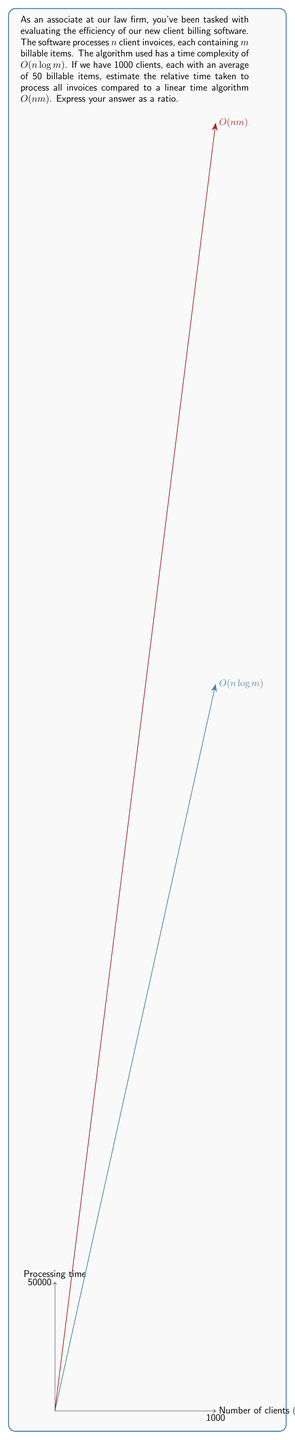Solve this math problem. Let's approach this step-by-step:

1) The given time complexity for the new algorithm is $O(n \log m)$, where:
   $n$ = number of clients = 1000
   $m$ = average number of billable items per client = 50

2) The linear time algorithm has a complexity of $O(nm)$

3) To compare, let's calculate the time for each:

   For $O(n \log m)$:
   Time $\approx c_1 \cdot n \log m = c_1 \cdot 1000 \log 50$

   For $O(nm)$:
   Time $\approx c_2 \cdot nm = c_2 \cdot 1000 \cdot 50 = c_2 \cdot 50000$

   Where $c_1$ and $c_2$ are constants.

4) The ratio of these times will be:

   $$\frac{\text{Time for } O(n \log m)}{\text{Time for } O(nm)} = \frac{c_1 \cdot 1000 \log 50}{c_2 \cdot 50000}$$

5) Assuming $c_1 \approx c_2$ (which is reasonable for comparing asymptotic complexities), we can simplify:

   $$\text{Ratio} \approx \frac{1000 \log 50}{50000} = \frac{\log 50}{50}$$

6) Calculate $\log 50$:
   $\log 50 \approx 5.64$ (using base-2 logarithm)

7) Final calculation:
   $$\frac{5.64}{50} \approx 0.1128$$

This means the new algorithm takes approximately 11.28% of the time that the linear algorithm would take.
Answer: $\frac{\log 50}{50} \approx 0.1128$ 